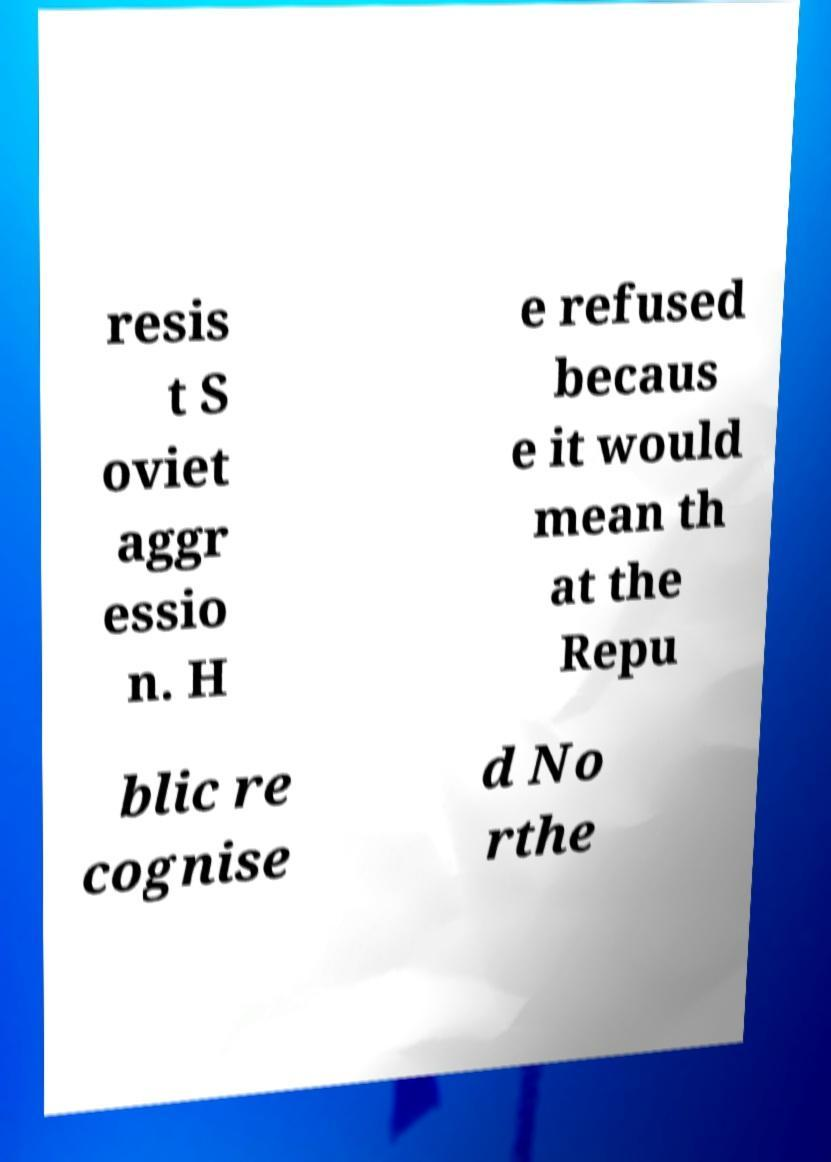Please identify and transcribe the text found in this image. resis t S oviet aggr essio n. H e refused becaus e it would mean th at the Repu blic re cognise d No rthe 